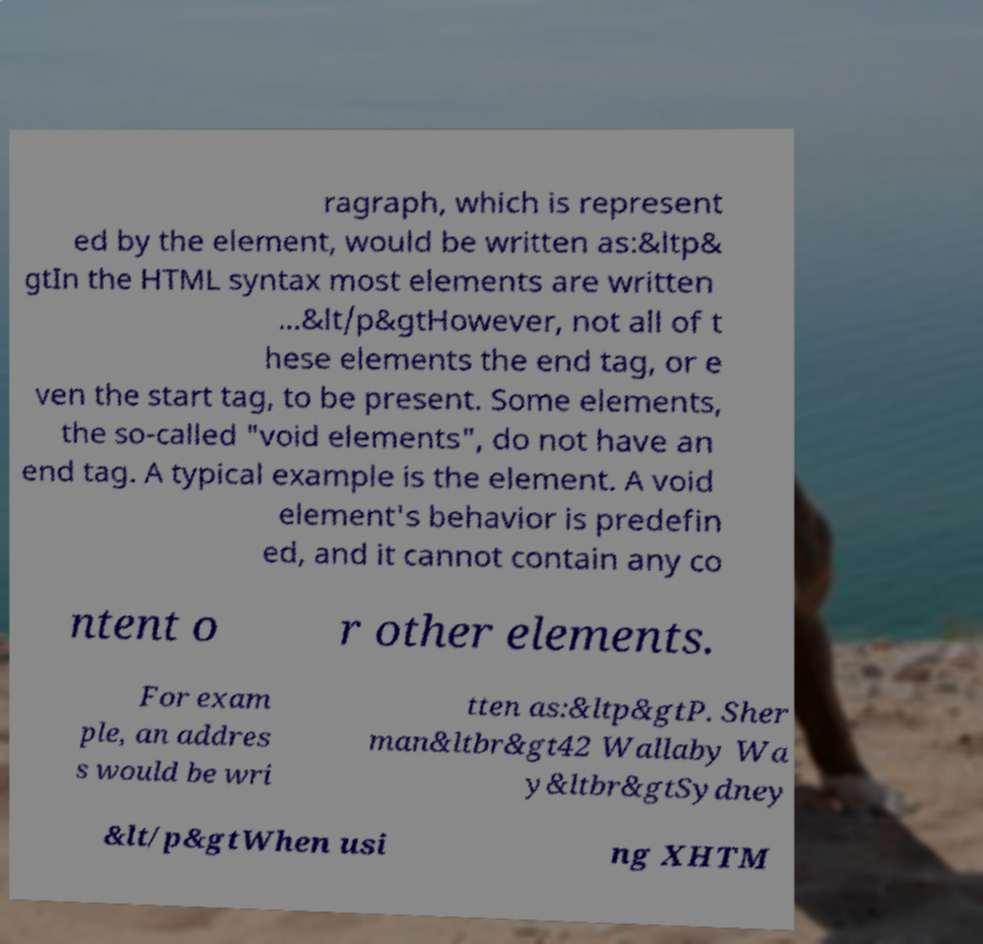Can you read and provide the text displayed in the image?This photo seems to have some interesting text. Can you extract and type it out for me? ragraph, which is represent ed by the element, would be written as:&ltp& gtIn the HTML syntax most elements are written ...&lt/p&gtHowever, not all of t hese elements the end tag, or e ven the start tag, to be present. Some elements, the so-called "void elements", do not have an end tag. A typical example is the element. A void element's behavior is predefin ed, and it cannot contain any co ntent o r other elements. For exam ple, an addres s would be wri tten as:&ltp&gtP. Sher man&ltbr&gt42 Wallaby Wa y&ltbr&gtSydney &lt/p&gtWhen usi ng XHTM 